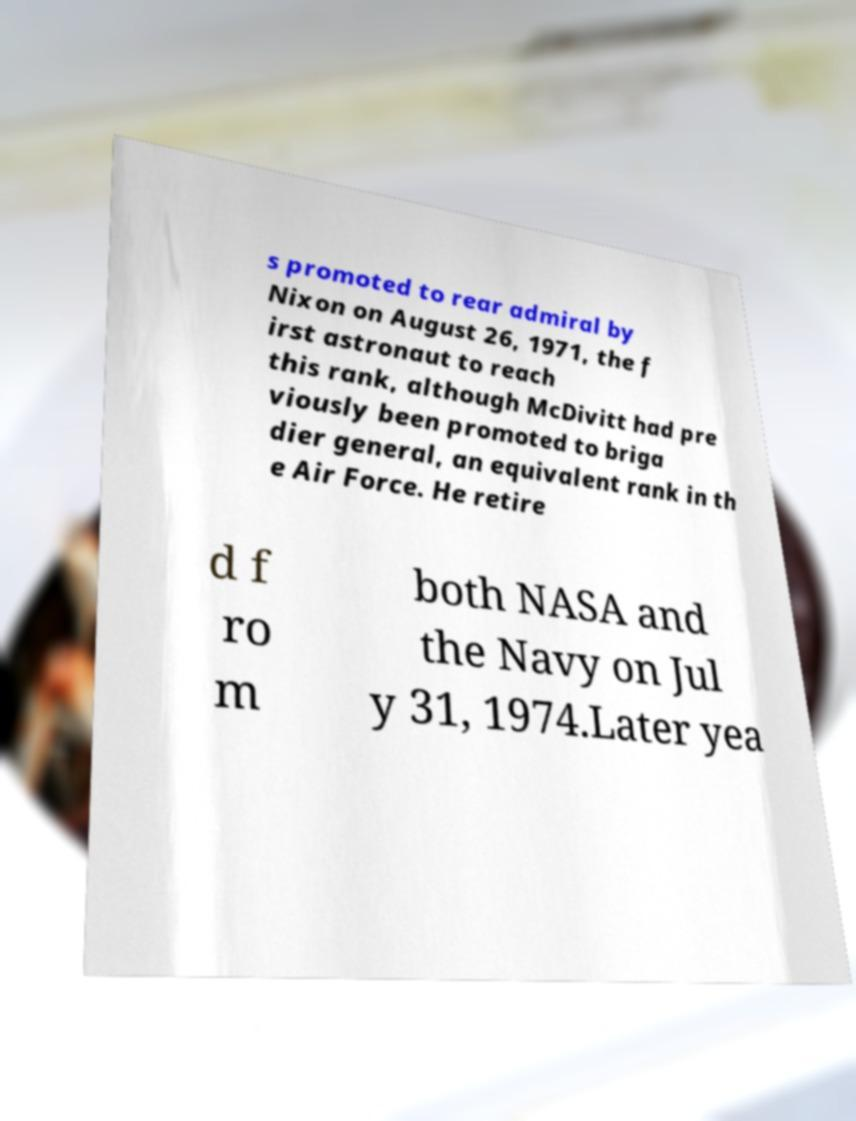There's text embedded in this image that I need extracted. Can you transcribe it verbatim? s promoted to rear admiral by Nixon on August 26, 1971, the f irst astronaut to reach this rank, although McDivitt had pre viously been promoted to briga dier general, an equivalent rank in th e Air Force. He retire d f ro m both NASA and the Navy on Jul y 31, 1974.Later yea 